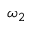Convert formula to latex. <formula><loc_0><loc_0><loc_500><loc_500>\omega _ { 2 }</formula> 